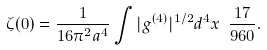<formula> <loc_0><loc_0><loc_500><loc_500>\zeta ( 0 ) = \frac { 1 } { 1 6 \pi ^ { 2 } a ^ { 4 } } \int | g ^ { ( 4 ) } | ^ { 1 / 2 } d ^ { 4 } x \ \frac { 1 7 } { 9 6 0 } .</formula> 